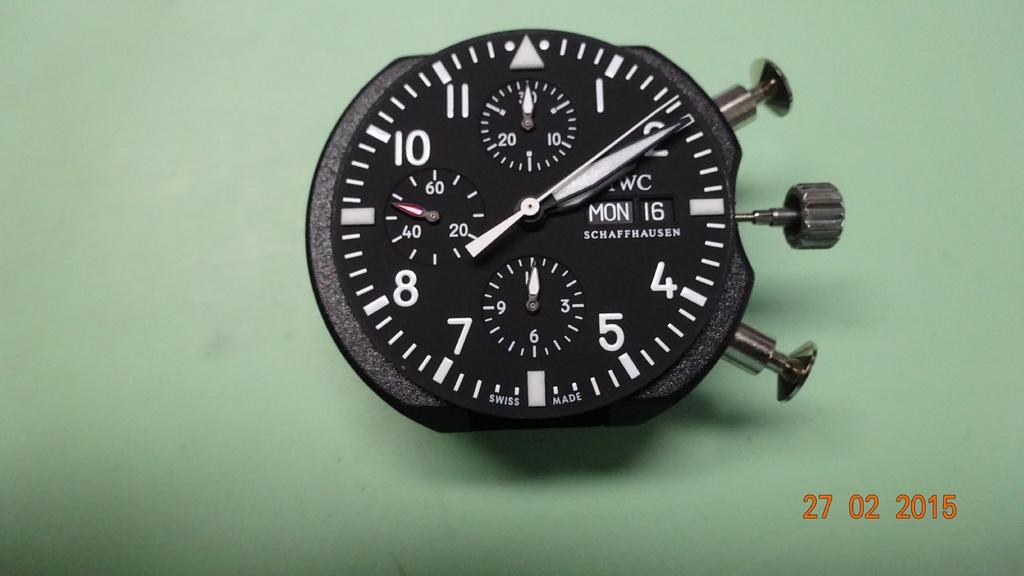What time is being shown?
Provide a succinct answer. 2:10. 